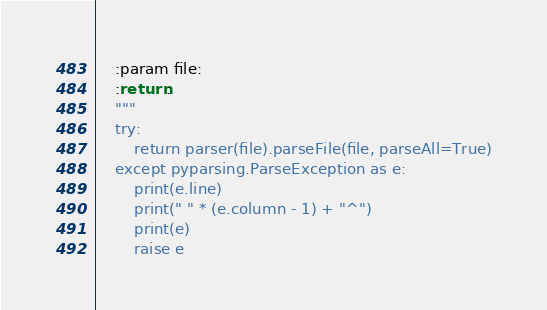Convert code to text. <code><loc_0><loc_0><loc_500><loc_500><_Python_>    :param file:
    :return:
    """
    try:
        return parser(file).parseFile(file, parseAll=True)
    except pyparsing.ParseException as e:
        print(e.line)
        print(" " * (e.column - 1) + "^")
        print(e)
        raise e</code> 